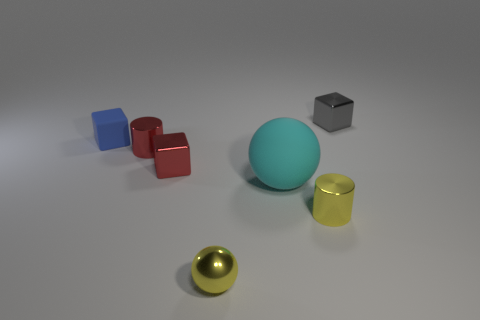Add 1 tiny cyan rubber spheres. How many objects exist? 8 Subtract all balls. How many objects are left? 5 Add 5 small blue rubber objects. How many small blue rubber objects exist? 6 Subtract 1 yellow cylinders. How many objects are left? 6 Subtract all shiny blocks. Subtract all tiny red cylinders. How many objects are left? 4 Add 4 red cylinders. How many red cylinders are left? 5 